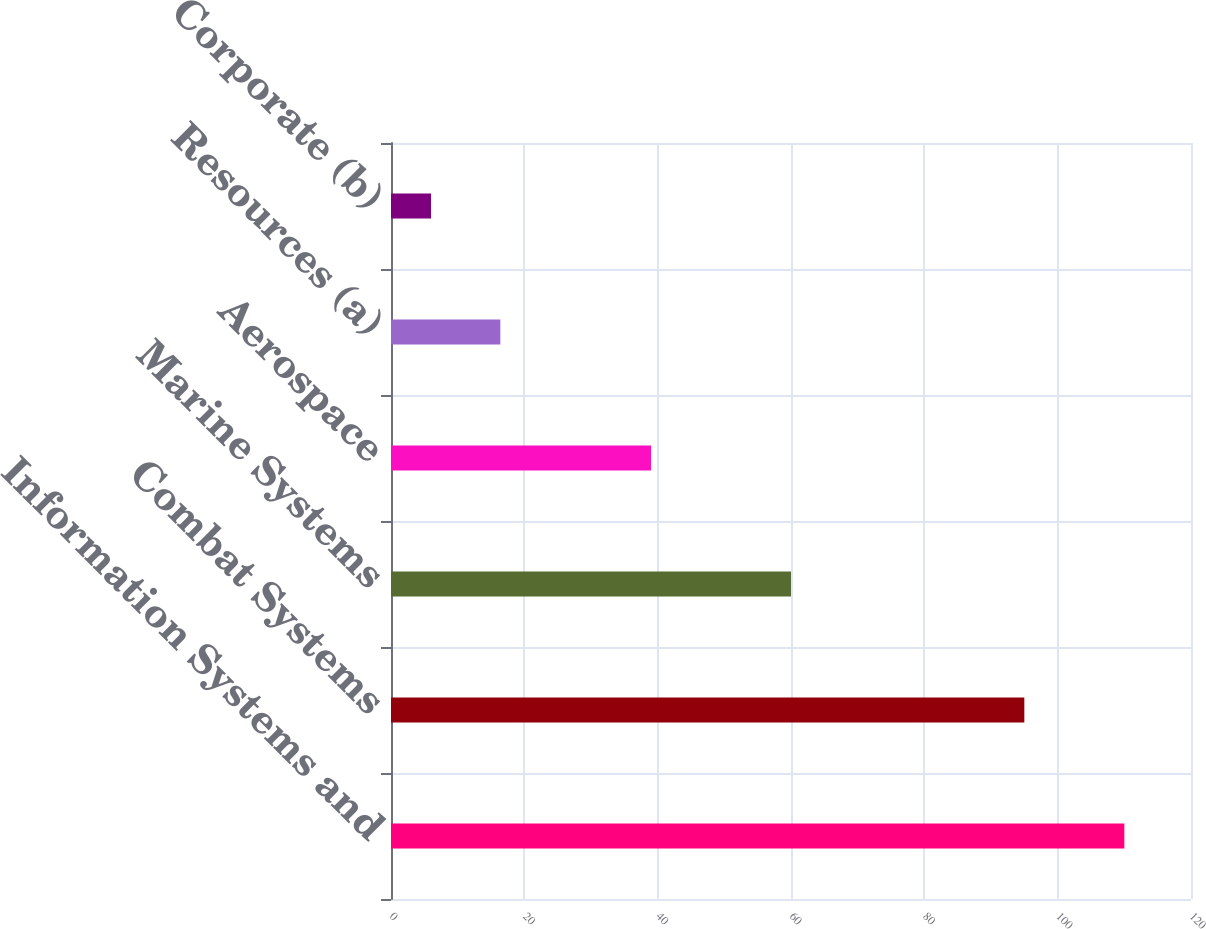Convert chart. <chart><loc_0><loc_0><loc_500><loc_500><bar_chart><fcel>Information Systems and<fcel>Combat Systems<fcel>Marine Systems<fcel>Aerospace<fcel>Resources (a)<fcel>Corporate (b)<nl><fcel>110<fcel>95<fcel>60<fcel>39<fcel>16.4<fcel>6<nl></chart> 